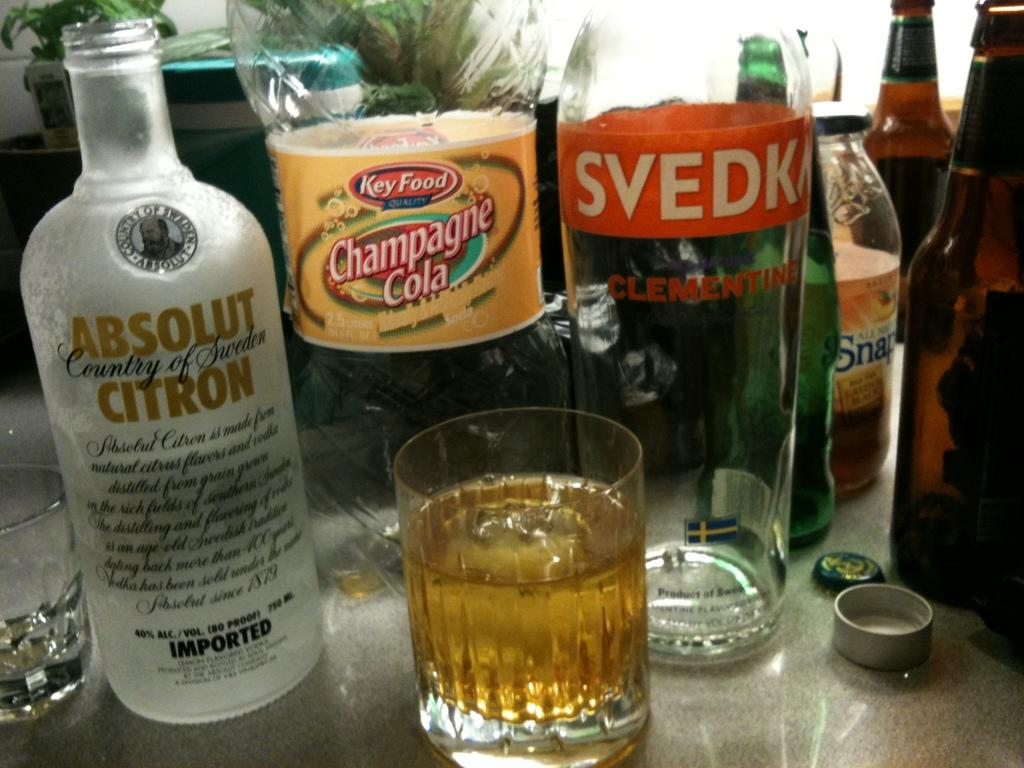<image>
Give a short and clear explanation of the subsequent image. A bottle of Absolut Citron is next to many other beverages. 